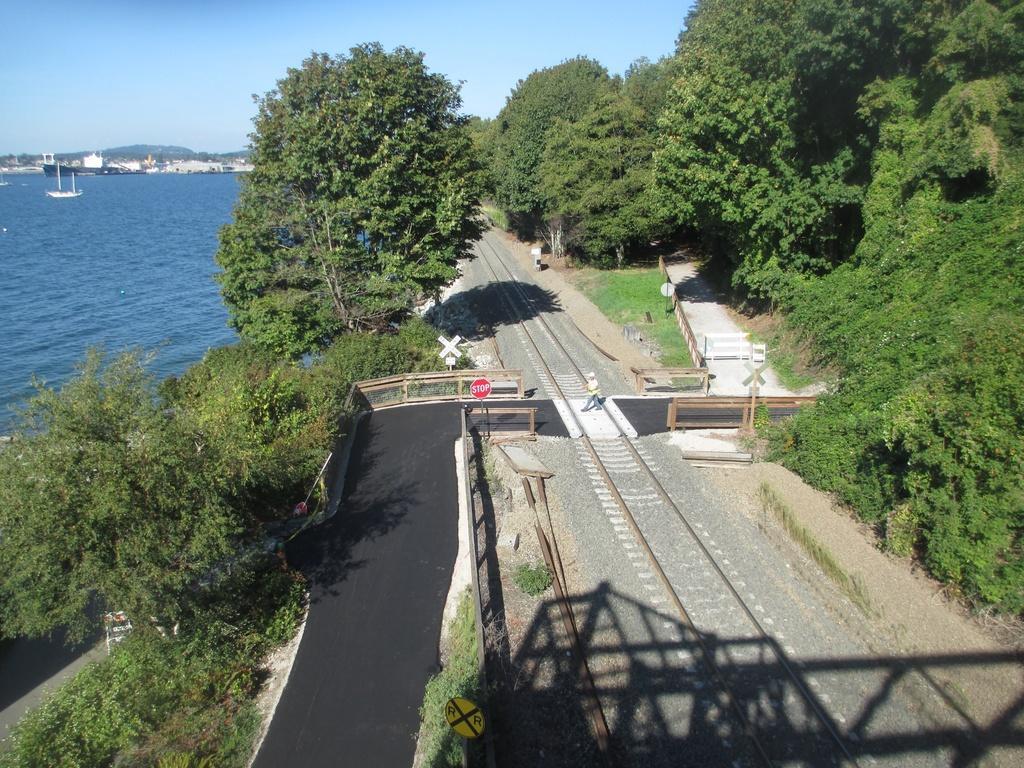In one or two sentences, can you explain what this image depicts? At the middle of the image we can see a track and a person crossing the track walking on the road, there are some trees at right side of the image and at left side of the image there is water and at the background of the image there are some buildings, mountains and clear sky. 